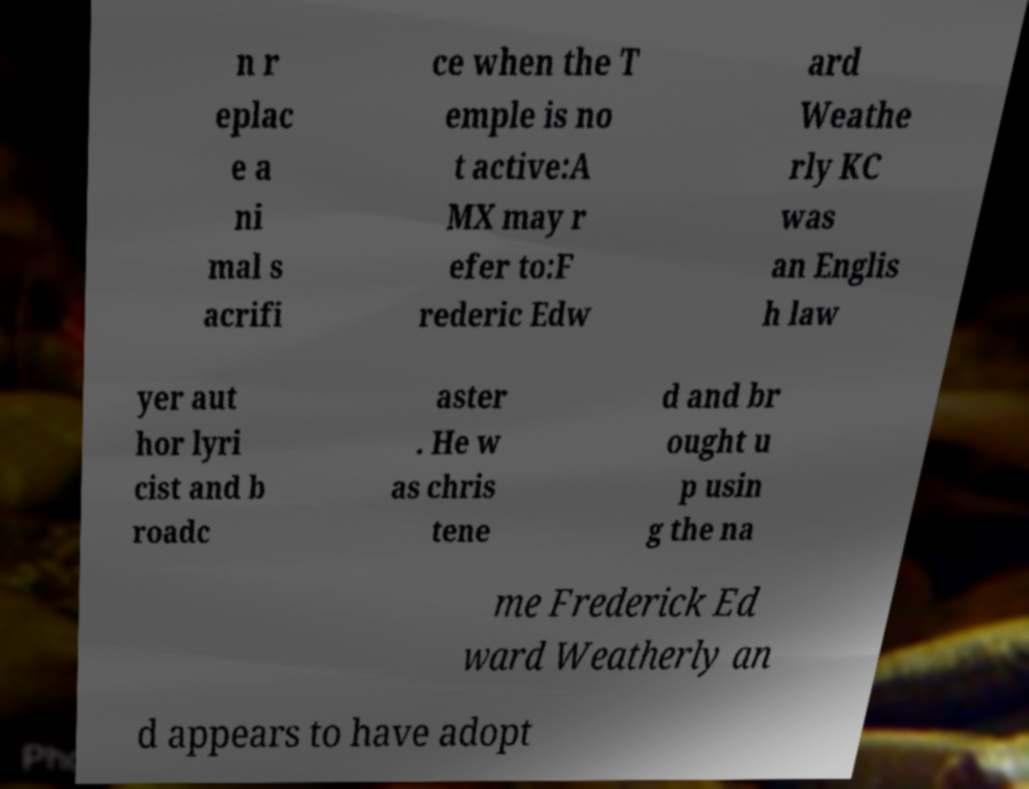What messages or text are displayed in this image? I need them in a readable, typed format. n r eplac e a ni mal s acrifi ce when the T emple is no t active:A MX may r efer to:F rederic Edw ard Weathe rly KC was an Englis h law yer aut hor lyri cist and b roadc aster . He w as chris tene d and br ought u p usin g the na me Frederick Ed ward Weatherly an d appears to have adopt 